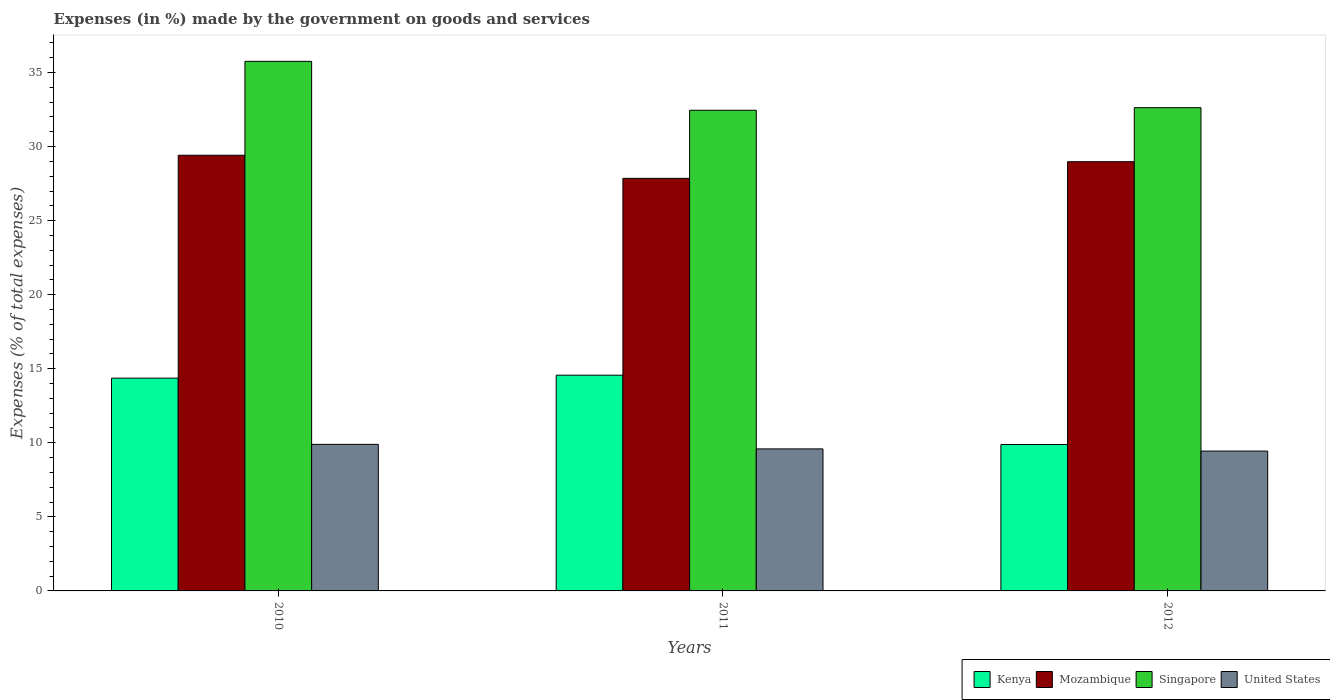Are the number of bars on each tick of the X-axis equal?
Provide a succinct answer. Yes. What is the percentage of expenses made by the government on goods and services in Mozambique in 2010?
Your answer should be very brief. 29.42. Across all years, what is the maximum percentage of expenses made by the government on goods and services in Mozambique?
Your answer should be compact. 29.42. Across all years, what is the minimum percentage of expenses made by the government on goods and services in Mozambique?
Provide a succinct answer. 27.85. In which year was the percentage of expenses made by the government on goods and services in Singapore minimum?
Make the answer very short. 2011. What is the total percentage of expenses made by the government on goods and services in Mozambique in the graph?
Make the answer very short. 86.25. What is the difference between the percentage of expenses made by the government on goods and services in Kenya in 2010 and that in 2011?
Your response must be concise. -0.2. What is the difference between the percentage of expenses made by the government on goods and services in United States in 2010 and the percentage of expenses made by the government on goods and services in Mozambique in 2012?
Keep it short and to the point. -19.08. What is the average percentage of expenses made by the government on goods and services in Mozambique per year?
Provide a short and direct response. 28.75. In the year 2011, what is the difference between the percentage of expenses made by the government on goods and services in United States and percentage of expenses made by the government on goods and services in Mozambique?
Keep it short and to the point. -18.26. In how many years, is the percentage of expenses made by the government on goods and services in Singapore greater than 13 %?
Give a very brief answer. 3. What is the ratio of the percentage of expenses made by the government on goods and services in Singapore in 2010 to that in 2011?
Offer a terse response. 1.1. What is the difference between the highest and the second highest percentage of expenses made by the government on goods and services in United States?
Provide a succinct answer. 0.31. What is the difference between the highest and the lowest percentage of expenses made by the government on goods and services in United States?
Offer a terse response. 0.45. In how many years, is the percentage of expenses made by the government on goods and services in Kenya greater than the average percentage of expenses made by the government on goods and services in Kenya taken over all years?
Your answer should be very brief. 2. Is the sum of the percentage of expenses made by the government on goods and services in United States in 2010 and 2012 greater than the maximum percentage of expenses made by the government on goods and services in Singapore across all years?
Provide a succinct answer. No. Is it the case that in every year, the sum of the percentage of expenses made by the government on goods and services in Kenya and percentage of expenses made by the government on goods and services in United States is greater than the sum of percentage of expenses made by the government on goods and services in Mozambique and percentage of expenses made by the government on goods and services in Singapore?
Keep it short and to the point. No. What does the 1st bar from the left in 2010 represents?
Ensure brevity in your answer.  Kenya. What does the 1st bar from the right in 2011 represents?
Your answer should be very brief. United States. How many bars are there?
Offer a terse response. 12. Are all the bars in the graph horizontal?
Offer a terse response. No. Are the values on the major ticks of Y-axis written in scientific E-notation?
Your response must be concise. No. Does the graph contain any zero values?
Your answer should be very brief. No. Does the graph contain grids?
Your answer should be very brief. No. How are the legend labels stacked?
Your response must be concise. Horizontal. What is the title of the graph?
Provide a short and direct response. Expenses (in %) made by the government on goods and services. Does "Latin America(all income levels)" appear as one of the legend labels in the graph?
Make the answer very short. No. What is the label or title of the Y-axis?
Give a very brief answer. Expenses (% of total expenses). What is the Expenses (% of total expenses) of Kenya in 2010?
Your answer should be very brief. 14.37. What is the Expenses (% of total expenses) of Mozambique in 2010?
Your answer should be very brief. 29.42. What is the Expenses (% of total expenses) in Singapore in 2010?
Make the answer very short. 35.75. What is the Expenses (% of total expenses) of United States in 2010?
Ensure brevity in your answer.  9.9. What is the Expenses (% of total expenses) of Kenya in 2011?
Give a very brief answer. 14.57. What is the Expenses (% of total expenses) of Mozambique in 2011?
Give a very brief answer. 27.85. What is the Expenses (% of total expenses) in Singapore in 2011?
Provide a short and direct response. 32.45. What is the Expenses (% of total expenses) in United States in 2011?
Your response must be concise. 9.59. What is the Expenses (% of total expenses) of Kenya in 2012?
Keep it short and to the point. 9.88. What is the Expenses (% of total expenses) of Mozambique in 2012?
Offer a terse response. 28.98. What is the Expenses (% of total expenses) in Singapore in 2012?
Give a very brief answer. 32.63. What is the Expenses (% of total expenses) of United States in 2012?
Ensure brevity in your answer.  9.44. Across all years, what is the maximum Expenses (% of total expenses) in Kenya?
Provide a short and direct response. 14.57. Across all years, what is the maximum Expenses (% of total expenses) in Mozambique?
Offer a terse response. 29.42. Across all years, what is the maximum Expenses (% of total expenses) of Singapore?
Offer a terse response. 35.75. Across all years, what is the maximum Expenses (% of total expenses) of United States?
Offer a very short reply. 9.9. Across all years, what is the minimum Expenses (% of total expenses) in Kenya?
Keep it short and to the point. 9.88. Across all years, what is the minimum Expenses (% of total expenses) of Mozambique?
Offer a terse response. 27.85. Across all years, what is the minimum Expenses (% of total expenses) in Singapore?
Ensure brevity in your answer.  32.45. Across all years, what is the minimum Expenses (% of total expenses) of United States?
Provide a short and direct response. 9.44. What is the total Expenses (% of total expenses) in Kenya in the graph?
Give a very brief answer. 38.82. What is the total Expenses (% of total expenses) in Mozambique in the graph?
Make the answer very short. 86.25. What is the total Expenses (% of total expenses) of Singapore in the graph?
Provide a succinct answer. 100.83. What is the total Expenses (% of total expenses) in United States in the graph?
Give a very brief answer. 28.93. What is the difference between the Expenses (% of total expenses) in Kenya in 2010 and that in 2011?
Your answer should be very brief. -0.2. What is the difference between the Expenses (% of total expenses) of Mozambique in 2010 and that in 2011?
Your response must be concise. 1.56. What is the difference between the Expenses (% of total expenses) of Singapore in 2010 and that in 2011?
Ensure brevity in your answer.  3.3. What is the difference between the Expenses (% of total expenses) in United States in 2010 and that in 2011?
Keep it short and to the point. 0.31. What is the difference between the Expenses (% of total expenses) in Kenya in 2010 and that in 2012?
Offer a terse response. 4.48. What is the difference between the Expenses (% of total expenses) in Mozambique in 2010 and that in 2012?
Ensure brevity in your answer.  0.44. What is the difference between the Expenses (% of total expenses) in Singapore in 2010 and that in 2012?
Make the answer very short. 3.13. What is the difference between the Expenses (% of total expenses) in United States in 2010 and that in 2012?
Provide a succinct answer. 0.45. What is the difference between the Expenses (% of total expenses) of Kenya in 2011 and that in 2012?
Provide a succinct answer. 4.68. What is the difference between the Expenses (% of total expenses) in Mozambique in 2011 and that in 2012?
Provide a short and direct response. -1.13. What is the difference between the Expenses (% of total expenses) of Singapore in 2011 and that in 2012?
Your response must be concise. -0.17. What is the difference between the Expenses (% of total expenses) in United States in 2011 and that in 2012?
Your response must be concise. 0.15. What is the difference between the Expenses (% of total expenses) in Kenya in 2010 and the Expenses (% of total expenses) in Mozambique in 2011?
Your answer should be compact. -13.49. What is the difference between the Expenses (% of total expenses) of Kenya in 2010 and the Expenses (% of total expenses) of Singapore in 2011?
Your answer should be very brief. -18.09. What is the difference between the Expenses (% of total expenses) of Kenya in 2010 and the Expenses (% of total expenses) of United States in 2011?
Offer a terse response. 4.78. What is the difference between the Expenses (% of total expenses) of Mozambique in 2010 and the Expenses (% of total expenses) of Singapore in 2011?
Offer a terse response. -3.04. What is the difference between the Expenses (% of total expenses) in Mozambique in 2010 and the Expenses (% of total expenses) in United States in 2011?
Provide a succinct answer. 19.83. What is the difference between the Expenses (% of total expenses) in Singapore in 2010 and the Expenses (% of total expenses) in United States in 2011?
Keep it short and to the point. 26.17. What is the difference between the Expenses (% of total expenses) of Kenya in 2010 and the Expenses (% of total expenses) of Mozambique in 2012?
Provide a succinct answer. -14.61. What is the difference between the Expenses (% of total expenses) of Kenya in 2010 and the Expenses (% of total expenses) of Singapore in 2012?
Make the answer very short. -18.26. What is the difference between the Expenses (% of total expenses) in Kenya in 2010 and the Expenses (% of total expenses) in United States in 2012?
Your answer should be compact. 4.92. What is the difference between the Expenses (% of total expenses) of Mozambique in 2010 and the Expenses (% of total expenses) of Singapore in 2012?
Keep it short and to the point. -3.21. What is the difference between the Expenses (% of total expenses) in Mozambique in 2010 and the Expenses (% of total expenses) in United States in 2012?
Your response must be concise. 19.97. What is the difference between the Expenses (% of total expenses) in Singapore in 2010 and the Expenses (% of total expenses) in United States in 2012?
Make the answer very short. 26.31. What is the difference between the Expenses (% of total expenses) of Kenya in 2011 and the Expenses (% of total expenses) of Mozambique in 2012?
Make the answer very short. -14.41. What is the difference between the Expenses (% of total expenses) of Kenya in 2011 and the Expenses (% of total expenses) of Singapore in 2012?
Keep it short and to the point. -18.06. What is the difference between the Expenses (% of total expenses) in Kenya in 2011 and the Expenses (% of total expenses) in United States in 2012?
Offer a very short reply. 5.12. What is the difference between the Expenses (% of total expenses) of Mozambique in 2011 and the Expenses (% of total expenses) of Singapore in 2012?
Your answer should be compact. -4.77. What is the difference between the Expenses (% of total expenses) of Mozambique in 2011 and the Expenses (% of total expenses) of United States in 2012?
Provide a short and direct response. 18.41. What is the difference between the Expenses (% of total expenses) in Singapore in 2011 and the Expenses (% of total expenses) in United States in 2012?
Your response must be concise. 23.01. What is the average Expenses (% of total expenses) of Kenya per year?
Make the answer very short. 12.94. What is the average Expenses (% of total expenses) of Mozambique per year?
Provide a succinct answer. 28.75. What is the average Expenses (% of total expenses) in Singapore per year?
Your answer should be very brief. 33.61. What is the average Expenses (% of total expenses) in United States per year?
Offer a very short reply. 9.64. In the year 2010, what is the difference between the Expenses (% of total expenses) in Kenya and Expenses (% of total expenses) in Mozambique?
Offer a terse response. -15.05. In the year 2010, what is the difference between the Expenses (% of total expenses) of Kenya and Expenses (% of total expenses) of Singapore?
Offer a terse response. -21.39. In the year 2010, what is the difference between the Expenses (% of total expenses) of Kenya and Expenses (% of total expenses) of United States?
Make the answer very short. 4.47. In the year 2010, what is the difference between the Expenses (% of total expenses) in Mozambique and Expenses (% of total expenses) in Singapore?
Give a very brief answer. -6.34. In the year 2010, what is the difference between the Expenses (% of total expenses) in Mozambique and Expenses (% of total expenses) in United States?
Your answer should be very brief. 19.52. In the year 2010, what is the difference between the Expenses (% of total expenses) in Singapore and Expenses (% of total expenses) in United States?
Provide a short and direct response. 25.86. In the year 2011, what is the difference between the Expenses (% of total expenses) of Kenya and Expenses (% of total expenses) of Mozambique?
Keep it short and to the point. -13.29. In the year 2011, what is the difference between the Expenses (% of total expenses) in Kenya and Expenses (% of total expenses) in Singapore?
Provide a succinct answer. -17.89. In the year 2011, what is the difference between the Expenses (% of total expenses) in Kenya and Expenses (% of total expenses) in United States?
Your answer should be very brief. 4.98. In the year 2011, what is the difference between the Expenses (% of total expenses) in Mozambique and Expenses (% of total expenses) in Singapore?
Give a very brief answer. -4.6. In the year 2011, what is the difference between the Expenses (% of total expenses) of Mozambique and Expenses (% of total expenses) of United States?
Make the answer very short. 18.26. In the year 2011, what is the difference between the Expenses (% of total expenses) in Singapore and Expenses (% of total expenses) in United States?
Make the answer very short. 22.86. In the year 2012, what is the difference between the Expenses (% of total expenses) in Kenya and Expenses (% of total expenses) in Mozambique?
Your response must be concise. -19.09. In the year 2012, what is the difference between the Expenses (% of total expenses) in Kenya and Expenses (% of total expenses) in Singapore?
Give a very brief answer. -22.74. In the year 2012, what is the difference between the Expenses (% of total expenses) in Kenya and Expenses (% of total expenses) in United States?
Your answer should be very brief. 0.44. In the year 2012, what is the difference between the Expenses (% of total expenses) of Mozambique and Expenses (% of total expenses) of Singapore?
Your answer should be very brief. -3.65. In the year 2012, what is the difference between the Expenses (% of total expenses) of Mozambique and Expenses (% of total expenses) of United States?
Offer a very short reply. 19.54. In the year 2012, what is the difference between the Expenses (% of total expenses) of Singapore and Expenses (% of total expenses) of United States?
Provide a short and direct response. 23.18. What is the ratio of the Expenses (% of total expenses) of Kenya in 2010 to that in 2011?
Ensure brevity in your answer.  0.99. What is the ratio of the Expenses (% of total expenses) of Mozambique in 2010 to that in 2011?
Provide a succinct answer. 1.06. What is the ratio of the Expenses (% of total expenses) of Singapore in 2010 to that in 2011?
Ensure brevity in your answer.  1.1. What is the ratio of the Expenses (% of total expenses) in United States in 2010 to that in 2011?
Your answer should be very brief. 1.03. What is the ratio of the Expenses (% of total expenses) of Kenya in 2010 to that in 2012?
Offer a very short reply. 1.45. What is the ratio of the Expenses (% of total expenses) in Mozambique in 2010 to that in 2012?
Provide a short and direct response. 1.01. What is the ratio of the Expenses (% of total expenses) of Singapore in 2010 to that in 2012?
Provide a succinct answer. 1.1. What is the ratio of the Expenses (% of total expenses) in United States in 2010 to that in 2012?
Offer a very short reply. 1.05. What is the ratio of the Expenses (% of total expenses) in Kenya in 2011 to that in 2012?
Provide a succinct answer. 1.47. What is the ratio of the Expenses (% of total expenses) in Mozambique in 2011 to that in 2012?
Make the answer very short. 0.96. What is the ratio of the Expenses (% of total expenses) in Singapore in 2011 to that in 2012?
Your response must be concise. 0.99. What is the ratio of the Expenses (% of total expenses) of United States in 2011 to that in 2012?
Give a very brief answer. 1.02. What is the difference between the highest and the second highest Expenses (% of total expenses) of Kenya?
Keep it short and to the point. 0.2. What is the difference between the highest and the second highest Expenses (% of total expenses) in Mozambique?
Offer a terse response. 0.44. What is the difference between the highest and the second highest Expenses (% of total expenses) in Singapore?
Offer a terse response. 3.13. What is the difference between the highest and the second highest Expenses (% of total expenses) of United States?
Provide a succinct answer. 0.31. What is the difference between the highest and the lowest Expenses (% of total expenses) of Kenya?
Provide a short and direct response. 4.68. What is the difference between the highest and the lowest Expenses (% of total expenses) in Mozambique?
Keep it short and to the point. 1.56. What is the difference between the highest and the lowest Expenses (% of total expenses) of Singapore?
Your answer should be very brief. 3.3. What is the difference between the highest and the lowest Expenses (% of total expenses) of United States?
Ensure brevity in your answer.  0.45. 